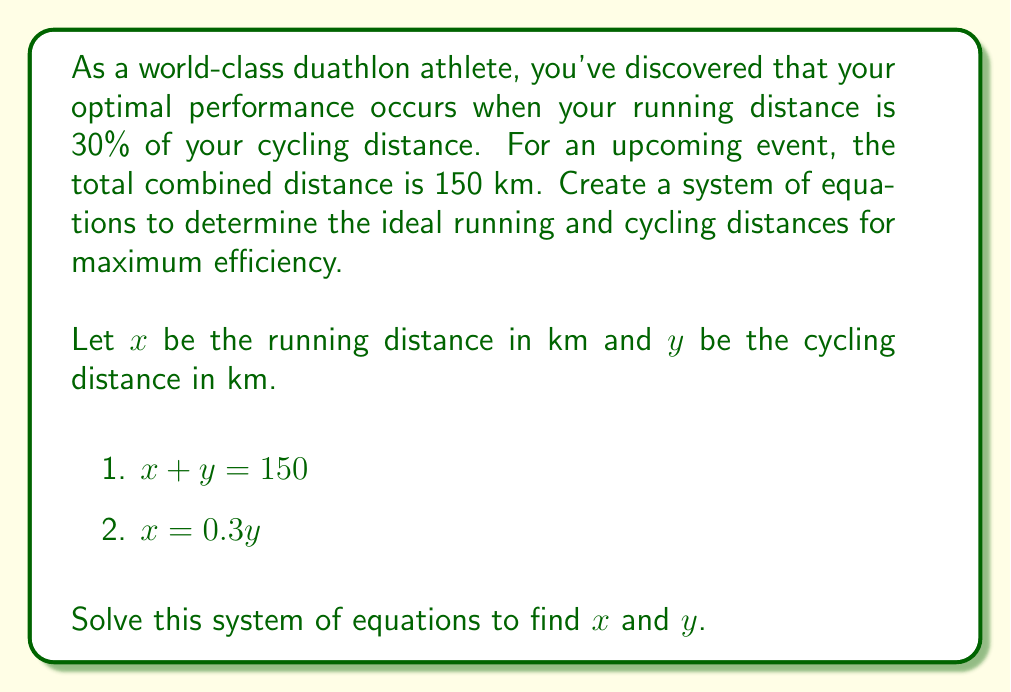Could you help me with this problem? To solve this system of equations, we'll use the substitution method:

1) From the second equation, we know that $x = 0.3y$

2) Substitute this into the first equation:
   $0.3y + y = 150$

3) Simplify:
   $1.3y = 150$

4) Solve for $y$:
   $y = \frac{150}{1.3} \approx 115.38$ km

5) Now that we know $y$, we can find $x$ using the second equation:
   $x = 0.3y = 0.3 \times 115.38 \approx 34.62$ km

6) Let's verify that these values satisfy both original equations:
   
   Equation 1: $x + y = 34.62 + 115.38 = 150$ ✓
   Equation 2: $x = 0.3y \rightarrow 34.62 = 0.3 \times 115.38$ ✓

Therefore, the ideal running distance is approximately 34.62 km, and the ideal cycling distance is approximately 115.38 km.
Answer: Running distance: $x \approx 34.62$ km
Cycling distance: $y \approx 115.38$ km 